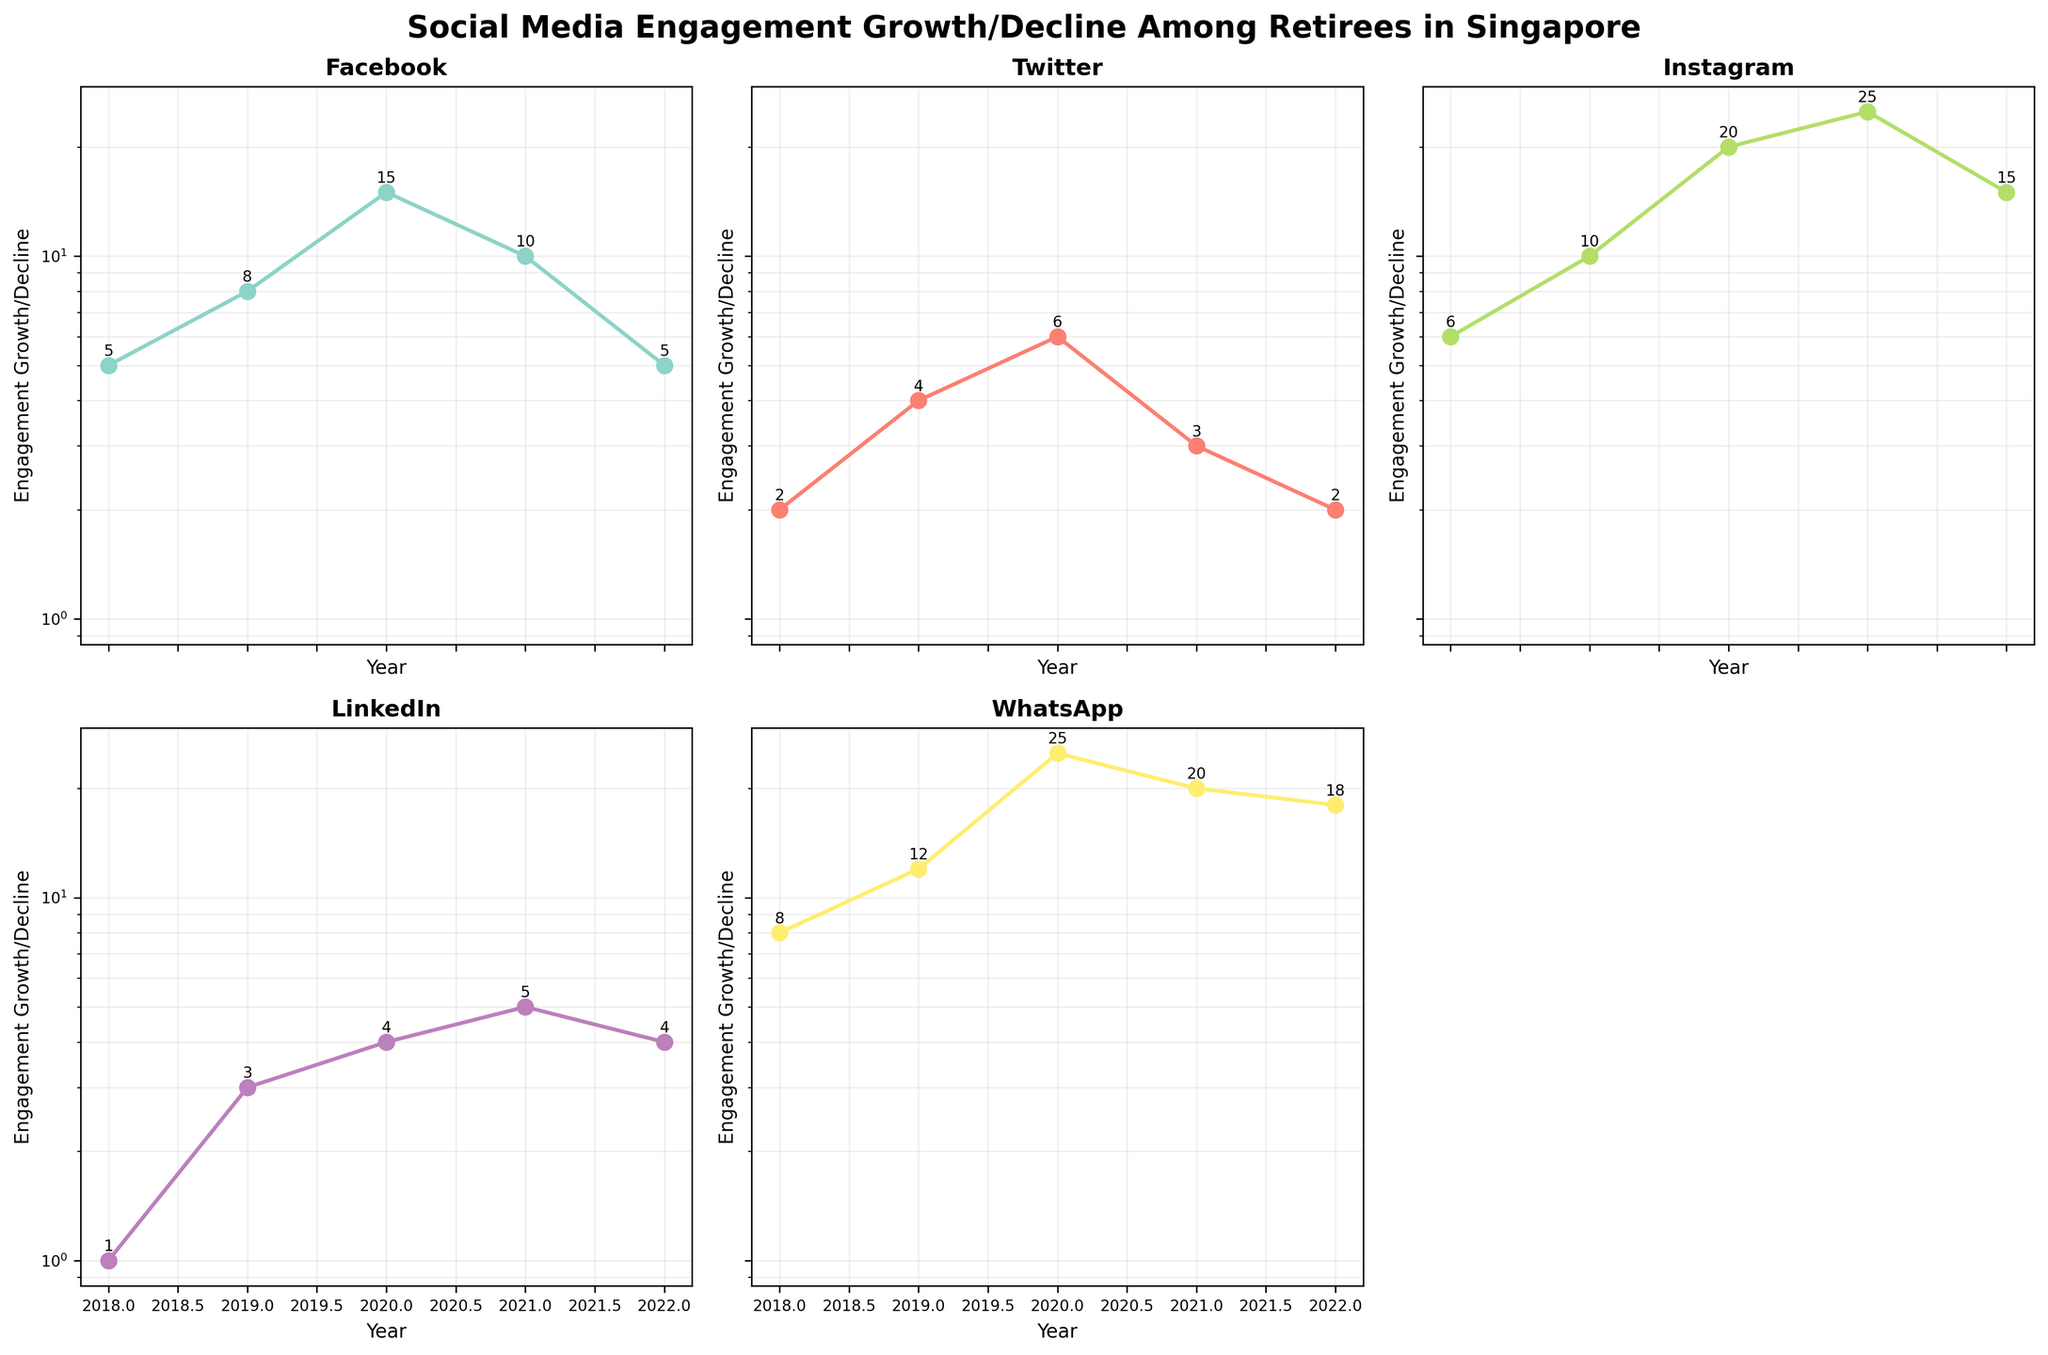What's the title of the figure? The title is prominently shown at the top center of the figure. It provides a summary of what the figure represents.
Answer: Social Media Engagement Growth/Decline Among Retirees in Singapore Which platform had the highest engagement growth in any given year? Looking across the subplots, the platform with the highest engagement growth in any year is clearly marked with numerical annotations near the highest data point.
Answer: Instagram in 2021 How many data points are displayed for each platform? Each subplot represents one platform and shows data points for each year from 2018 to 2022. Counting these points gives the number of data points per platform.
Answer: 5 In which year did Facebook see its highest engagement growth? Referring to the subplot for Facebook, the highest point is in 2020 and the value is annotated beside the data point.
Answer: 2020 Which platform experienced a decline in engagement growth from 2021 to 2022? By observing the slopes from 2021 to 2022 in each subplot, a downward trend indicates a decline. Multiple platforms show this trend. One notable example is Facebook.
Answer: Facebook Compare the engagement growth between WhatsApp and LinkedIn in 2020. Which is higher and by how much? In the WhatsApp subplot for 2020, the engagement growth is 25. In the LinkedIn subplot for the same year, it is 4. Subtracting the lower value from the higher one gives the difference.
Answer: WhatsApp by 21 Which platform had the lowest engagement growth in 2018? Looking at the lowest points for the year 2018 in each subplot, the values are annotated for clarity. LinkedIn has the lowest at 1.
Answer: LinkedIn What is the average engagement growth for Twitter over the years? Summing the engagement growth values for each year in the Twitter subplot and dividing by the number of years (5) gives the average. ((2+4+6+3+2)/5)=3.4
Answer: 3.4 From 2018 to 2020, which platform had a consistent increase in engagement growth? Checking each subplot, the platforms that show continuous year-on-year increase from 2018 to 2020 can be identified by a steady upward trend.
Answer: Instagram What does a log scale on the y-axis imply about the changes in engagement growth? A log scale better visualizes proportional changes and reduces the effect of large differences, making it easier to compare growth rates.
Answer: Highlights proportional changes 